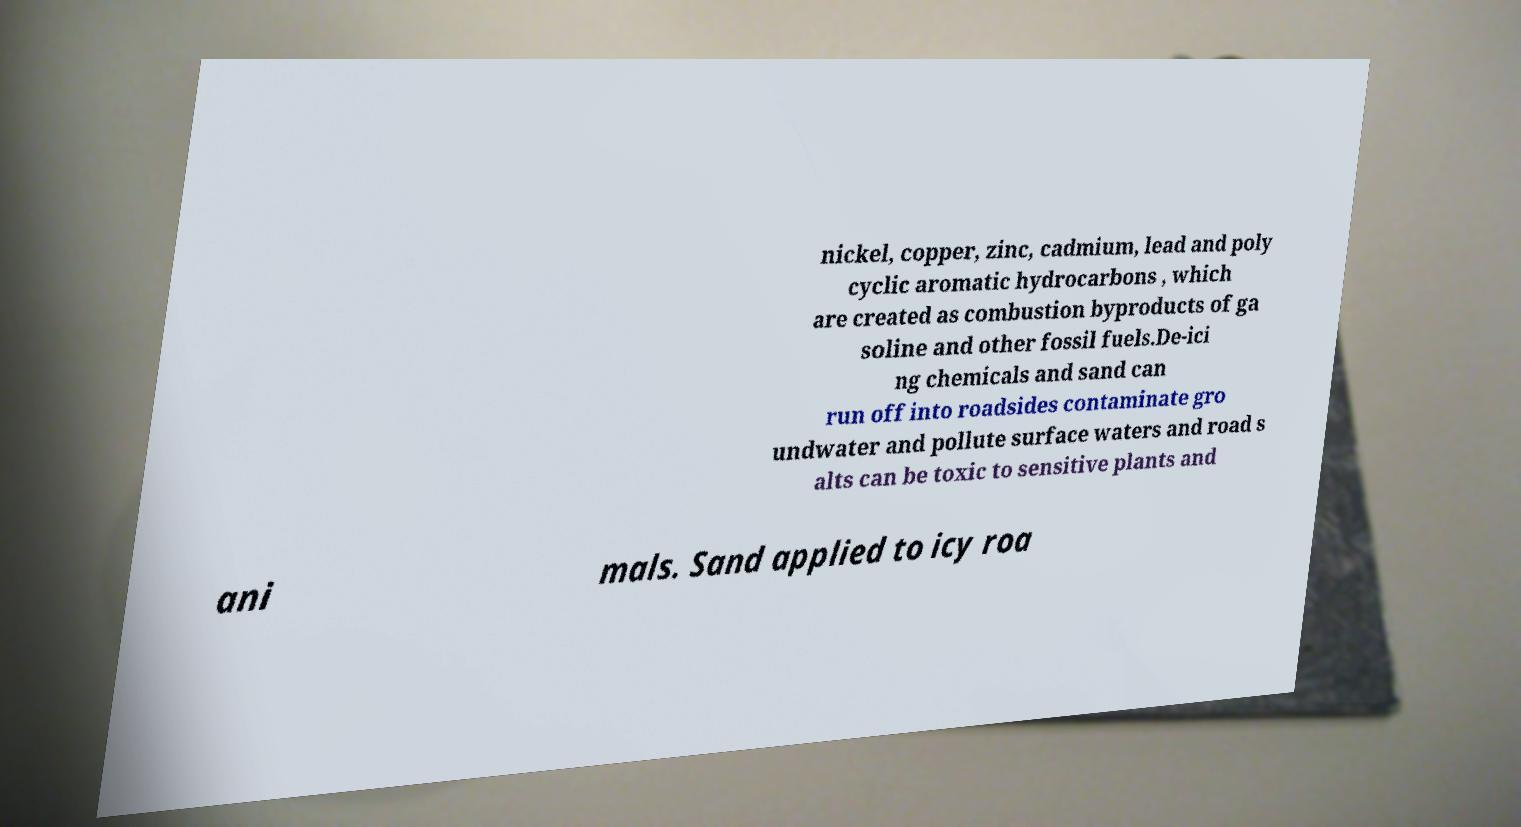Could you extract and type out the text from this image? nickel, copper, zinc, cadmium, lead and poly cyclic aromatic hydrocarbons , which are created as combustion byproducts of ga soline and other fossil fuels.De-ici ng chemicals and sand can run off into roadsides contaminate gro undwater and pollute surface waters and road s alts can be toxic to sensitive plants and ani mals. Sand applied to icy roa 